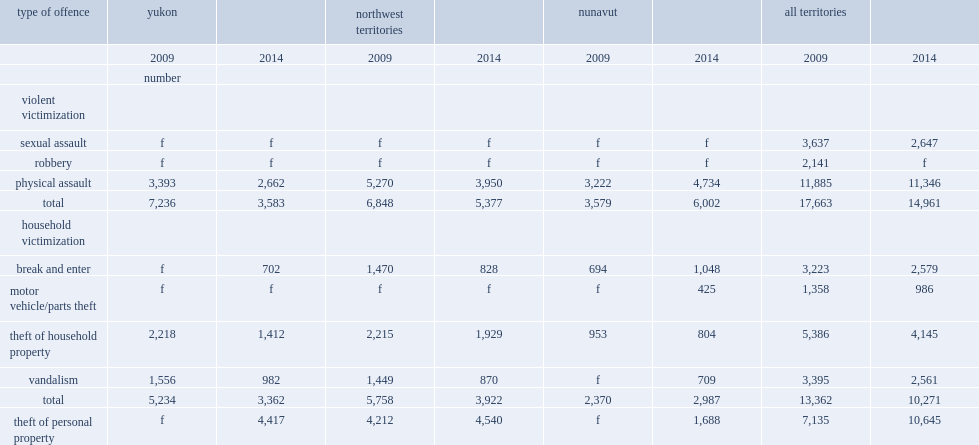How many violent incidents were reported by the residents of the territory in 2014? 14961.0. 